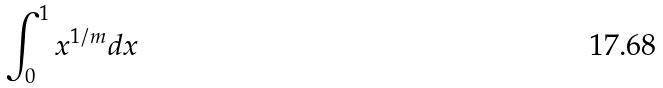<formula> <loc_0><loc_0><loc_500><loc_500>\int _ { 0 } ^ { 1 } x ^ { 1 / m } d x</formula> 